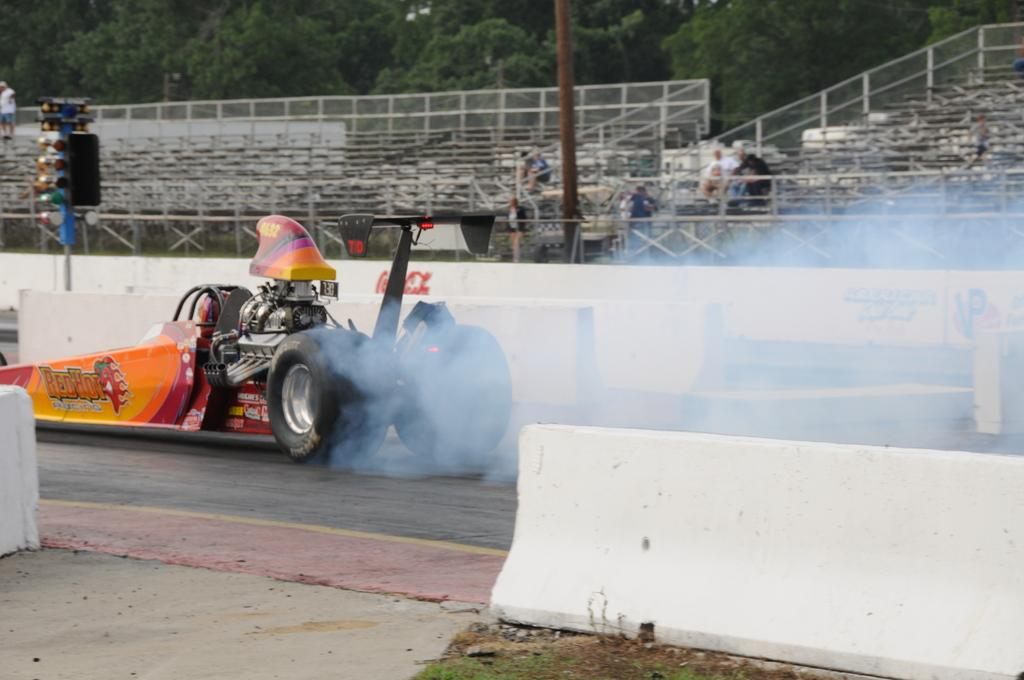What is the main subject of the image? There is a vehicle in the image. Can you describe the colors of the vehicle? The vehicle has orange and yellow colors. What else can be seen in the image besides the vehicle? There are poles, chairs, people sitting on the chairs, and trees with green color visible in the image. What type of instrument is being played by the people sitting on the chairs in the image? There is no instrument being played by the people sitting on the chairs in the image. What songs are the people singing while sitting on the chairs in the image? There is no indication of any singing or songs in the image. 